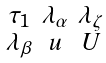Convert formula to latex. <formula><loc_0><loc_0><loc_500><loc_500>\begin{smallmatrix} \tau _ { 1 } & \lambda _ { \alpha } & \lambda _ { \zeta } \\ \lambda _ { \beta } & u & U \end{smallmatrix}</formula> 